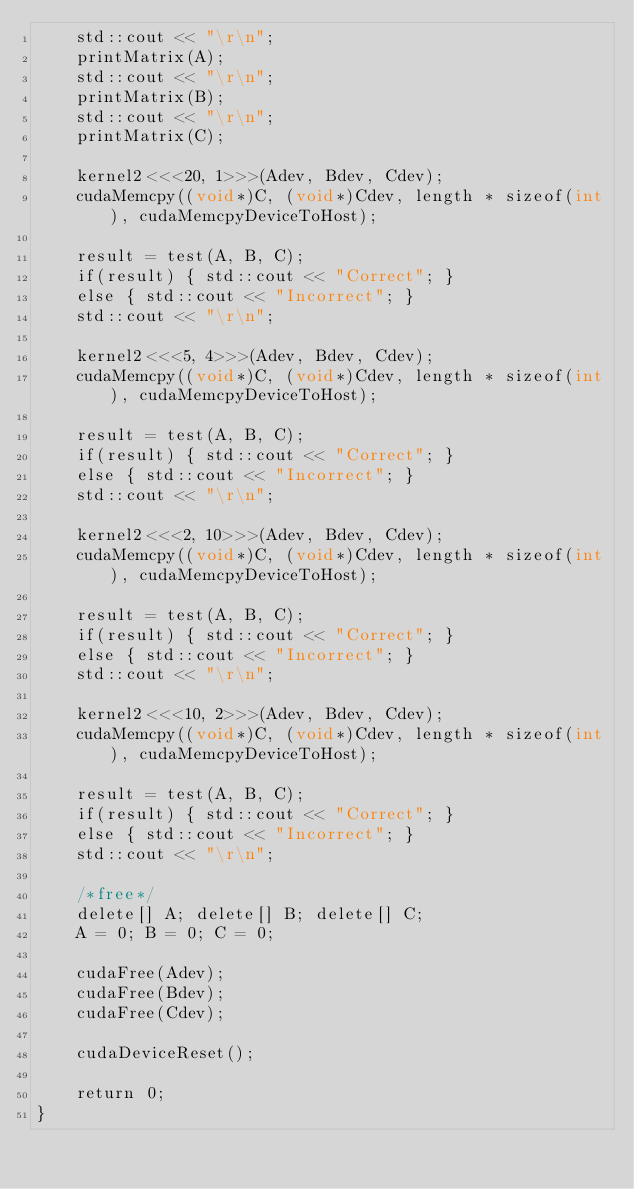Convert code to text. <code><loc_0><loc_0><loc_500><loc_500><_Cuda_>    std::cout << "\r\n";
    printMatrix(A);
    std::cout << "\r\n";
    printMatrix(B);
    std::cout << "\r\n";
    printMatrix(C);
	
    kernel2<<<20, 1>>>(Adev, Bdev, Cdev);
    cudaMemcpy((void*)C, (void*)Cdev, length * sizeof(int), cudaMemcpyDeviceToHost);
 
    result = test(A, B, C);
    if(result) { std::cout << "Correct"; }
    else { std::cout << "Incorrect"; }
    std::cout << "\r\n";
 
    kernel2<<<5, 4>>>(Adev, Bdev, Cdev);
    cudaMemcpy((void*)C, (void*)Cdev, length * sizeof(int), cudaMemcpyDeviceToHost);
 
    result = test(A, B, C);
    if(result) { std::cout << "Correct"; }
    else { std::cout << "Incorrect"; }
    std::cout << "\r\n";
 
    kernel2<<<2, 10>>>(Adev, Bdev, Cdev);
    cudaMemcpy((void*)C, (void*)Cdev, length * sizeof(int), cudaMemcpyDeviceToHost);
 
    result = test(A, B, C);
    if(result) { std::cout << "Correct"; }
    else { std::cout << "Incorrect"; }
    std::cout << "\r\n";
 
    kernel2<<<10, 2>>>(Adev, Bdev, Cdev);
    cudaMemcpy((void*)C, (void*)Cdev, length * sizeof(int), cudaMemcpyDeviceToHost);

    result = test(A, B, C);
    if(result) { std::cout << "Correct"; }
    else { std::cout << "Incorrect"; }
    std::cout << "\r\n";
 
    /*free*/
    delete[] A; delete[] B; delete[] C;
    A = 0; B = 0; C = 0;

    cudaFree(Adev);
    cudaFree(Bdev);
    cudaFree(Cdev);

    cudaDeviceReset();

    return 0;
}</code> 